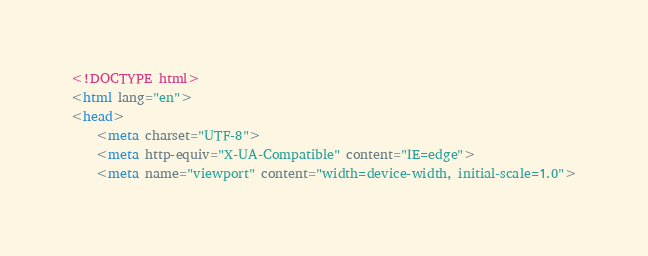<code> <loc_0><loc_0><loc_500><loc_500><_HTML_><!DOCTYPE html>
<html lang="en">
<head>
    <meta charset="UTF-8">
    <meta http-equiv="X-UA-Compatible" content="IE=edge">
    <meta name="viewport" content="width=device-width, initial-scale=1.0"></code> 